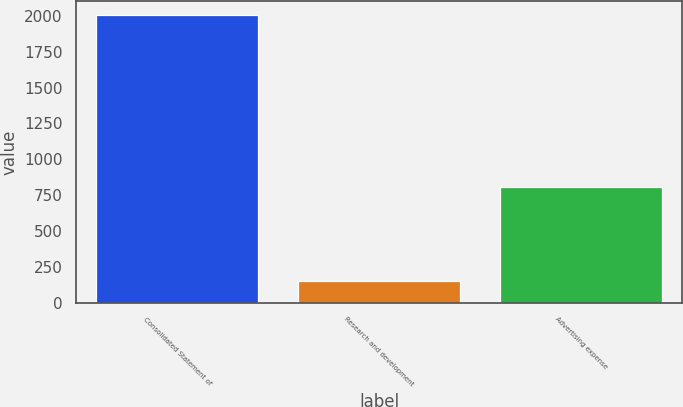Convert chart. <chart><loc_0><loc_0><loc_500><loc_500><bar_chart><fcel>Consolidated Statement of<fcel>Research and development<fcel>Advertising expense<nl><fcel>2004<fcel>148.9<fcel>806.2<nl></chart> 